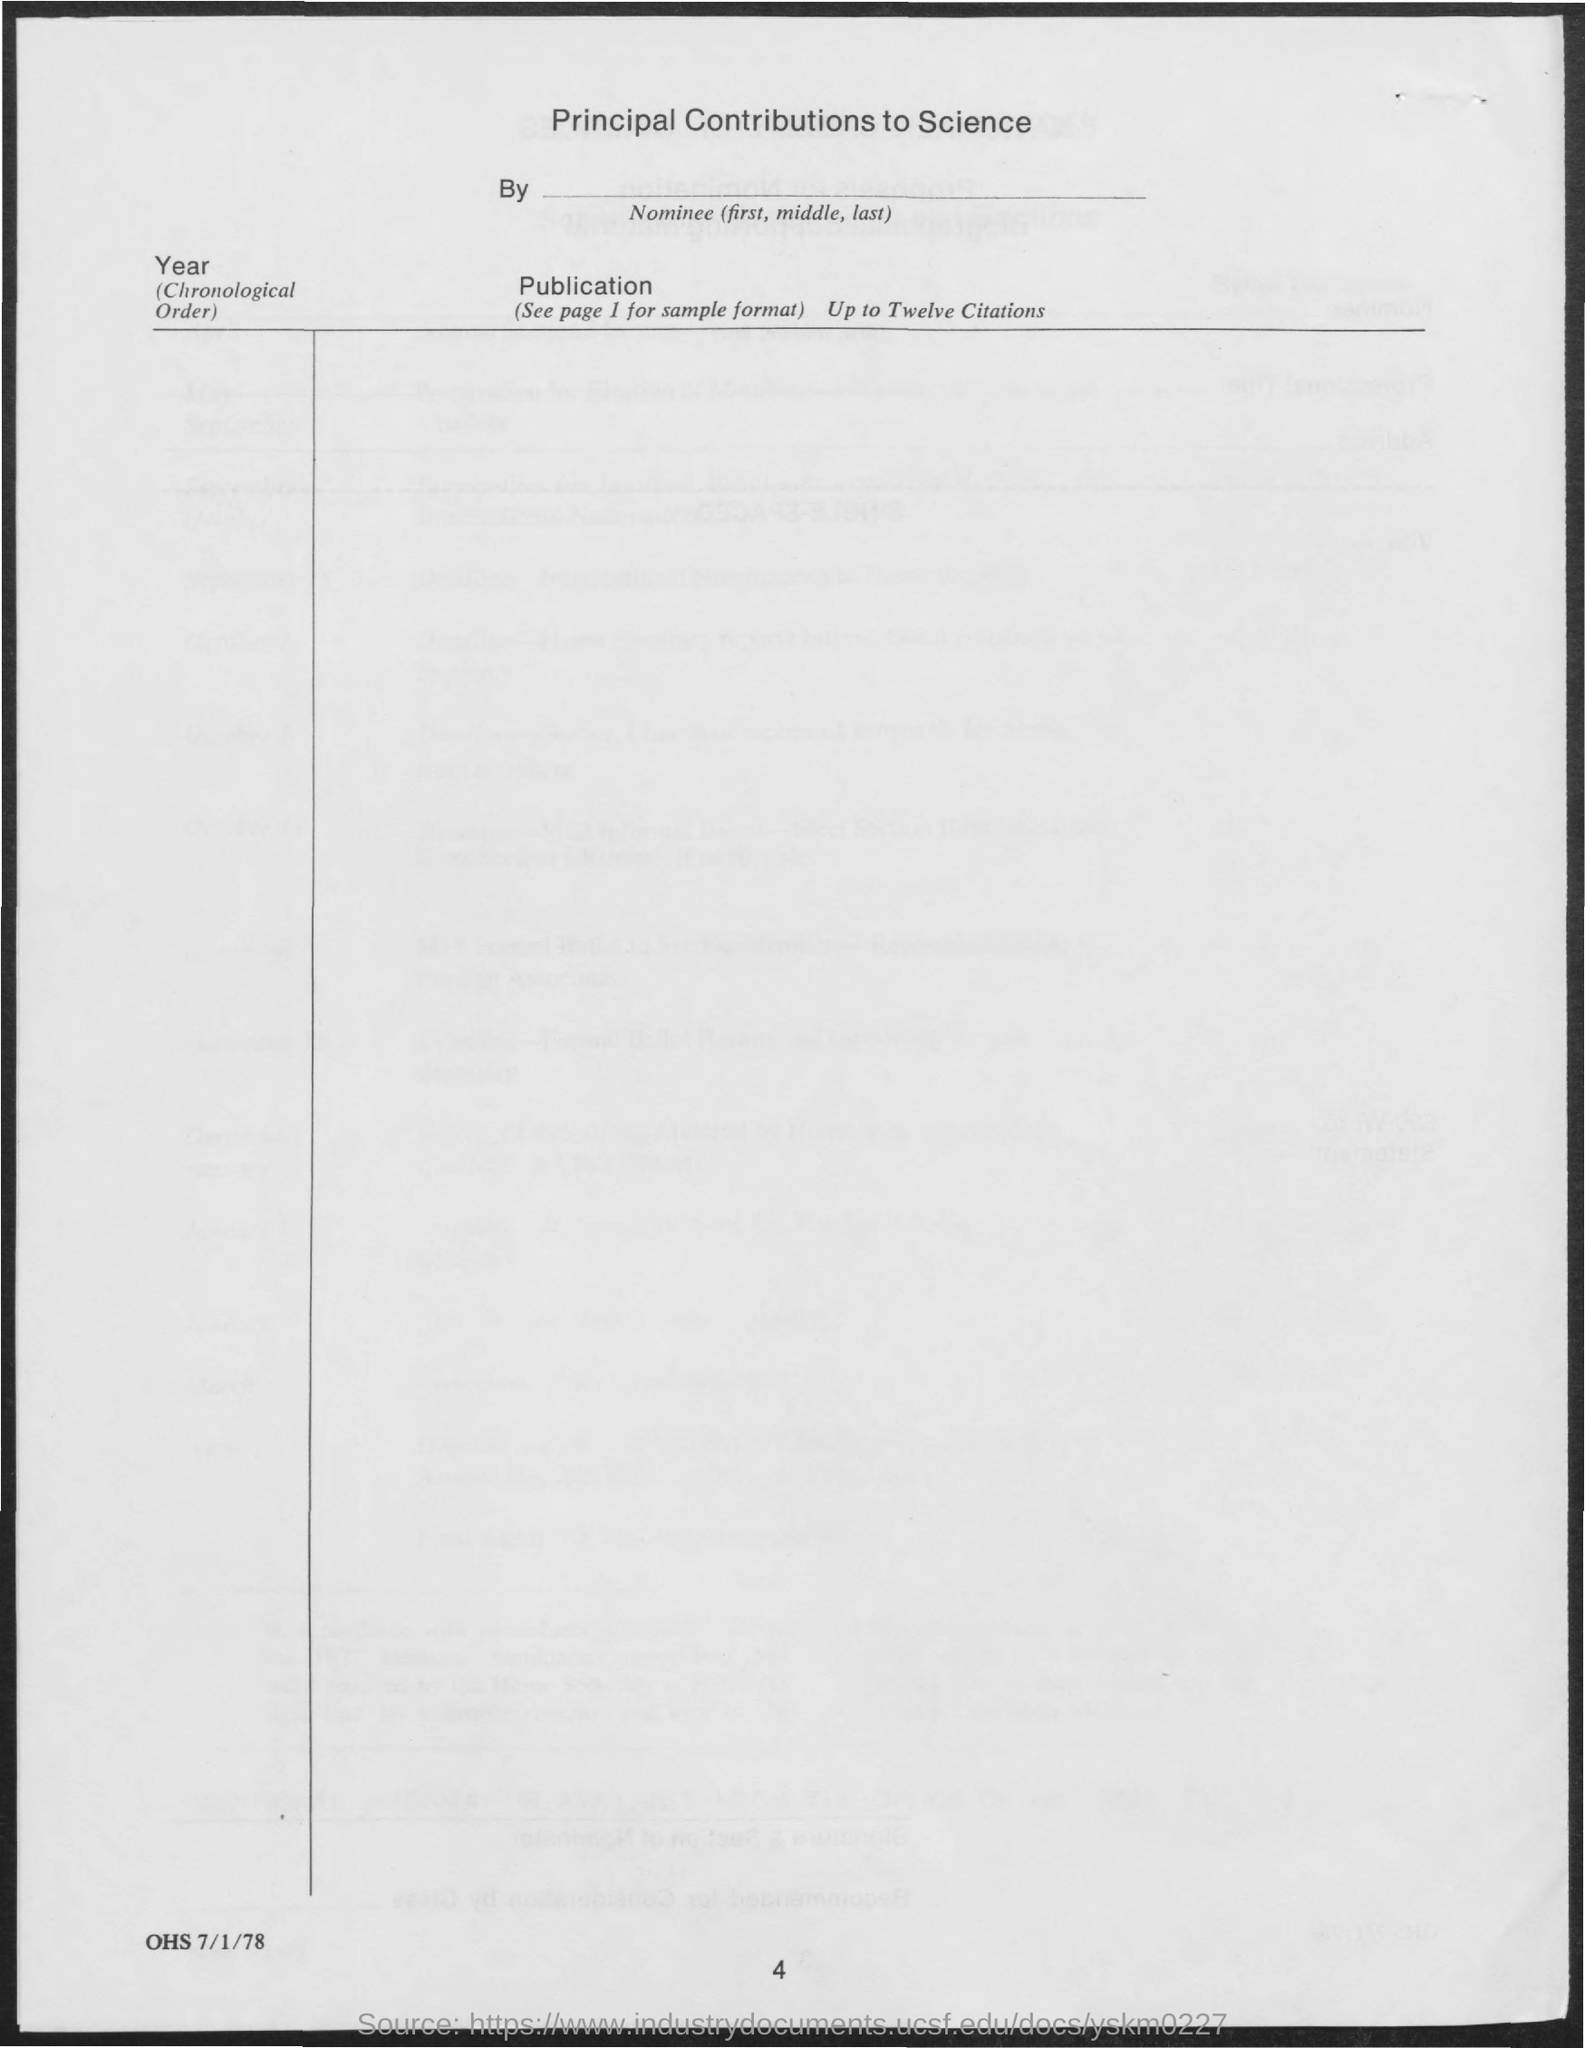Specify some key components in this picture. The title of this document is 'Principal Contributions to Science'. The heading for the second column is "Publication. The current page number is 4. It is essential to mention the year in chronological order. 